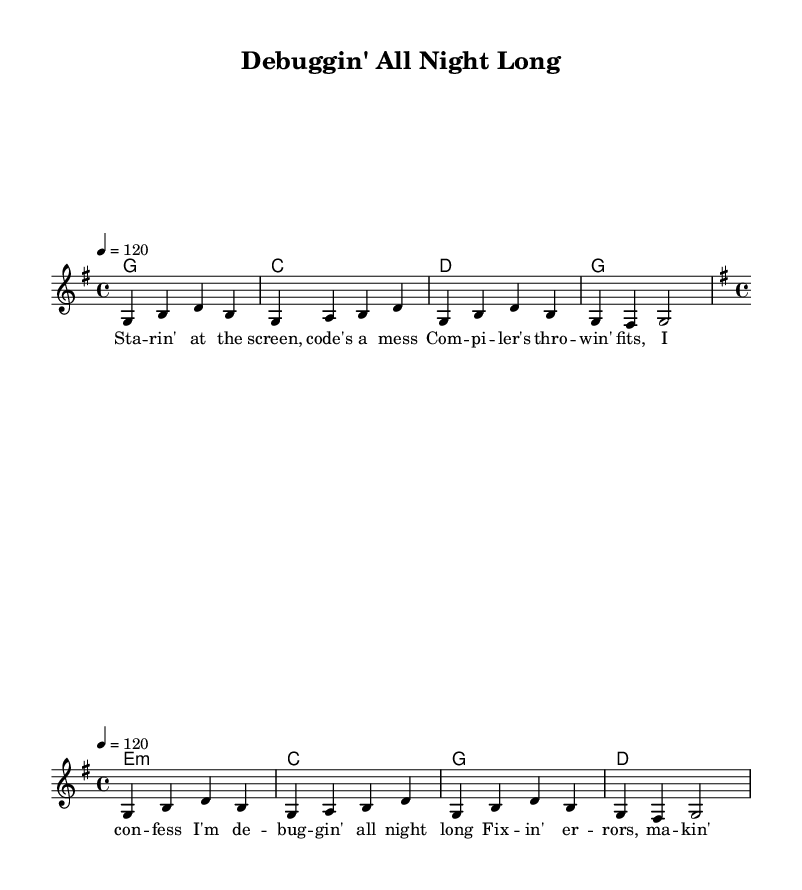What is the key signature of this music? The key signature is G major, which has one sharp (F#).
Answer: G major What is the time signature of this music? The time signature shown is 4/4, meaning there are four beats in each measure.
Answer: 4/4 What is the tempo marking of this music? The tempo marking indicates a speed of 120 beats per minute.
Answer: 120 How many measures are in the verse? The verse contains four measures, as indicated by the four lines of chords.
Answer: 4 What type of song structure is used in this piece? This piece uses a verse-chorus structure, where the verse is followed by the chorus.
Answer: Verse-Chorus What lyrical theme is presented in the song? The lyrics discuss coding challenges and debugging, reflecting a technical struggle.
Answer: Coding challenges How does the melody of the chorus differ from the verse in terms of dynamics? The melody of the chorus typically has a more upbeat and energetic feel compared to the verse.
Answer: More upbeat 